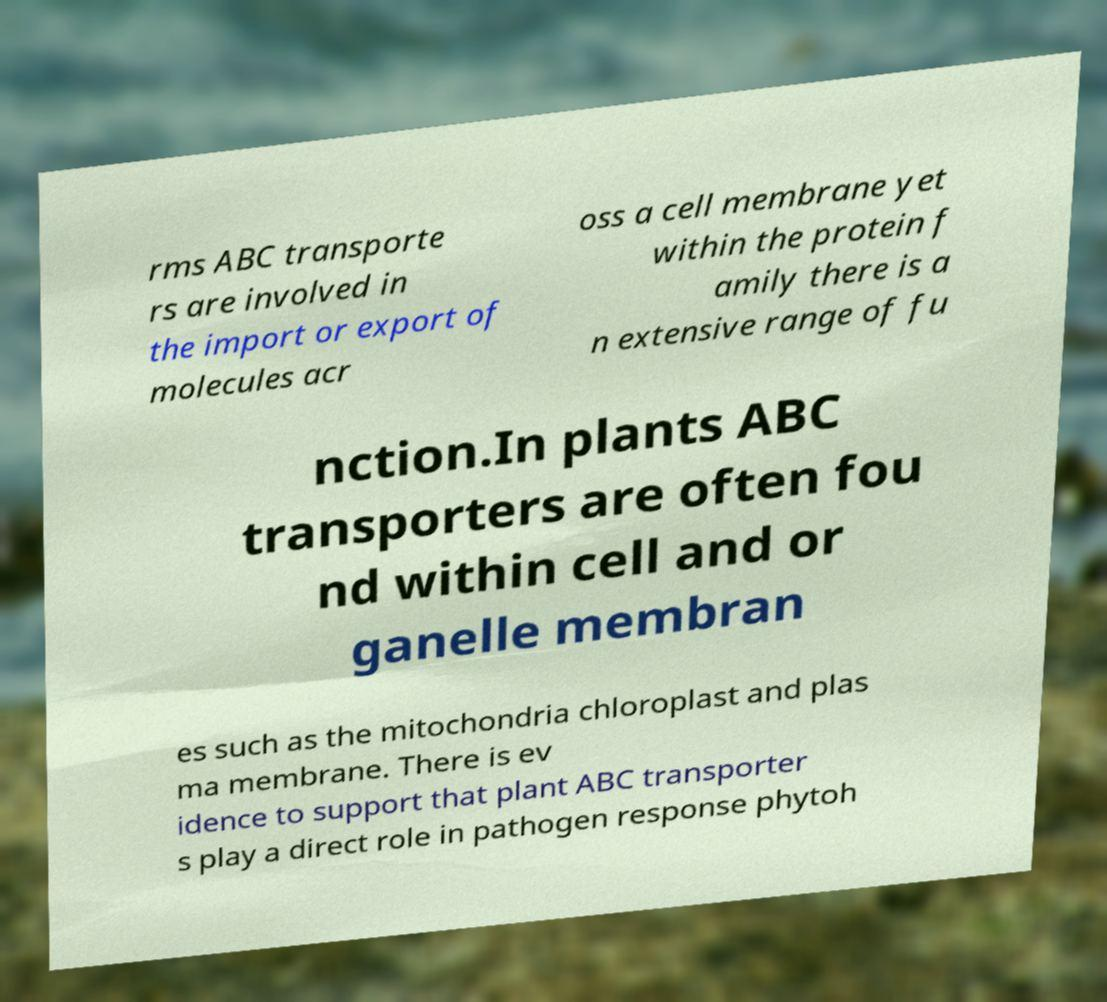I need the written content from this picture converted into text. Can you do that? rms ABC transporte rs are involved in the import or export of molecules acr oss a cell membrane yet within the protein f amily there is a n extensive range of fu nction.In plants ABC transporters are often fou nd within cell and or ganelle membran es such as the mitochondria chloroplast and plas ma membrane. There is ev idence to support that plant ABC transporter s play a direct role in pathogen response phytoh 